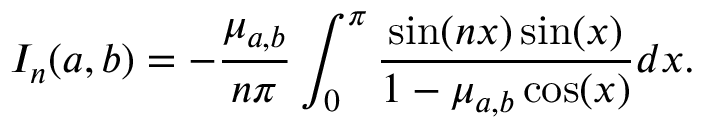<formula> <loc_0><loc_0><loc_500><loc_500>I _ { n } ( a , b ) = - \frac { \mu _ { a , b } } { n \pi } \int _ { 0 } ^ { \pi } \frac { \sin ( n x ) \sin ( x ) } { 1 - \mu _ { a , b } \cos ( x ) } d x .</formula> 